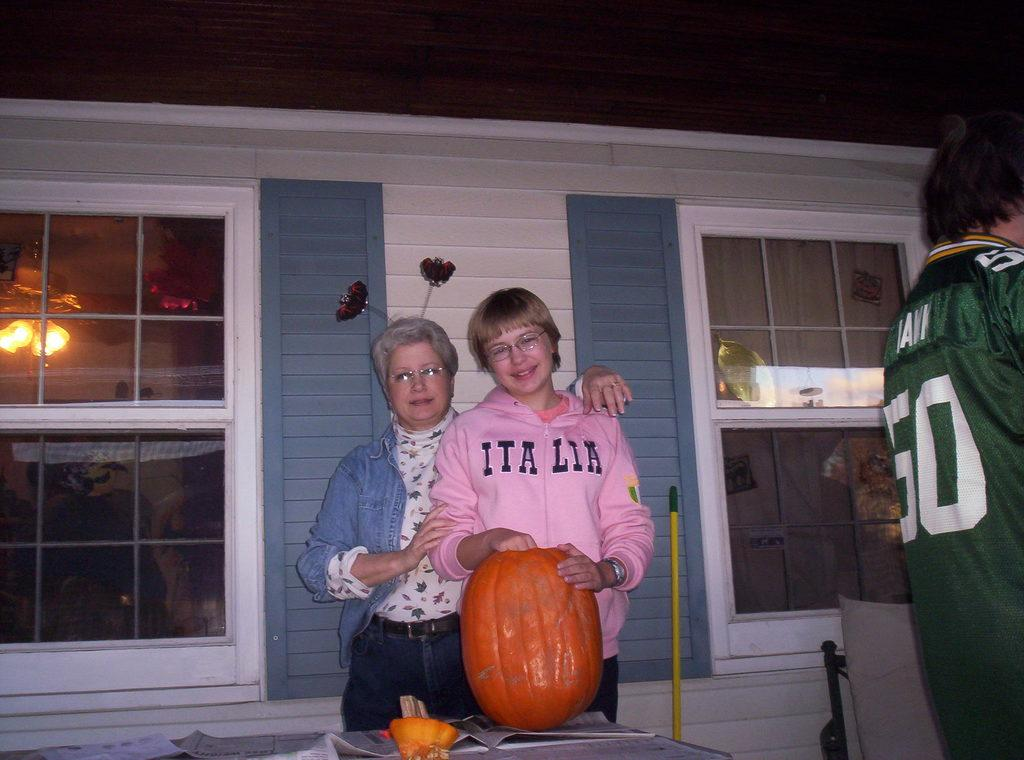<image>
Give a short and clear explanation of the subsequent image. A person in a Italia sweatshirt is carving a pumpkin. 